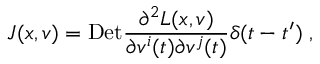Convert formula to latex. <formula><loc_0><loc_0><loc_500><loc_500>J ( x , v ) = D e t \frac { \partial ^ { 2 } L ( x , v ) } { \partial v ^ { i } ( t ) \partial v ^ { j } ( t ) } \delta ( t - t ^ { \prime } ) \, ,</formula> 